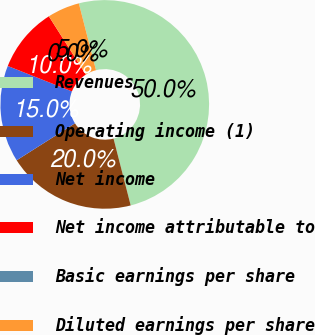Convert chart. <chart><loc_0><loc_0><loc_500><loc_500><pie_chart><fcel>Revenues<fcel>Operating income (1)<fcel>Net income<fcel>Net income attributable to<fcel>Basic earnings per share<fcel>Diluted earnings per share<nl><fcel>50.0%<fcel>20.0%<fcel>15.0%<fcel>10.0%<fcel>0.0%<fcel>5.0%<nl></chart> 